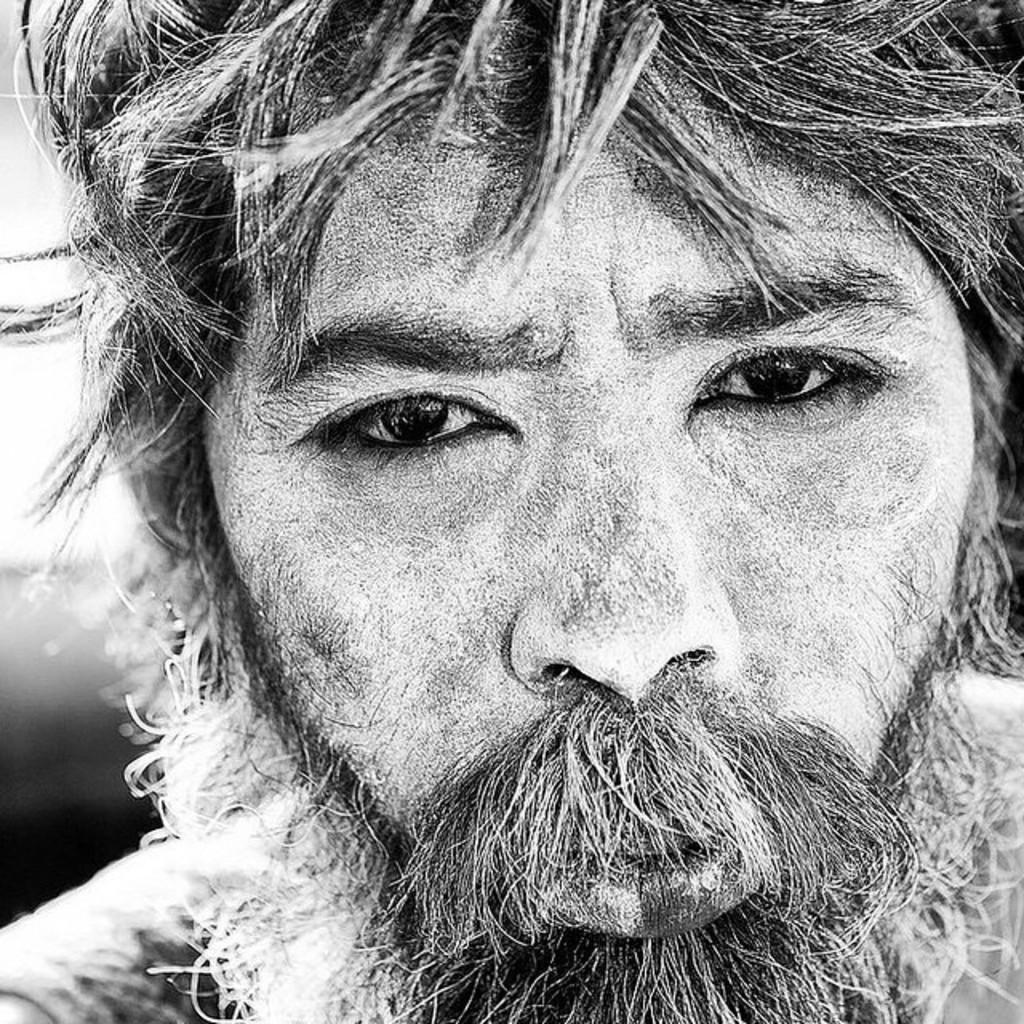What is the color scheme of the image? The image is black and white. Who or what is the main subject in the image? There is a person in the center of the image. Can you describe the background of the image? The background of the image is blurred. How many deer can be seen on the slope in the image? There are no deer or slopes present in the image; it features a person in a black and white setting with a blurred background. 